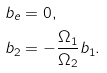<formula> <loc_0><loc_0><loc_500><loc_500>b _ { e } & = 0 , \\ b _ { 2 } & = - \frac { \Omega _ { 1 } } { \Omega _ { 2 } } b _ { 1 } .</formula> 